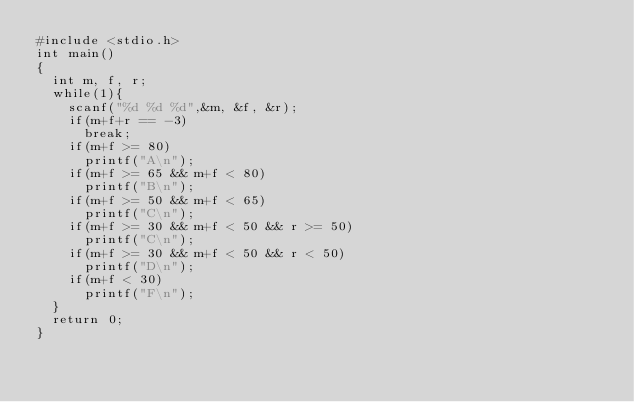<code> <loc_0><loc_0><loc_500><loc_500><_C_>#include <stdio.h>
int main()
{
	int m, f, r;
	while(1){
		scanf("%d %d %d",&m, &f, &r);
		if(m+f+r == -3)
			break;
		if(m+f >= 80)
			printf("A\n");
		if(m+f >= 65 && m+f < 80)
			printf("B\n");
		if(m+f >= 50 && m+f < 65)
			printf("C\n");
		if(m+f >= 30 && m+f < 50 && r >= 50)
			printf("C\n");
		if(m+f >= 30 && m+f < 50 && r < 50)
			printf("D\n");
		if(m+f < 30)
			printf("F\n");
	}
	return 0;
}</code> 